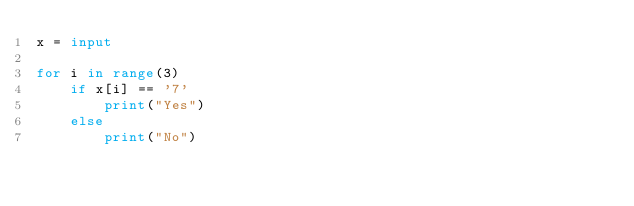Convert code to text. <code><loc_0><loc_0><loc_500><loc_500><_Python_>x = input

for i in range(3)
	if x[i] == '7'
  		print("Yes")
    else
    	print("No")

</code> 